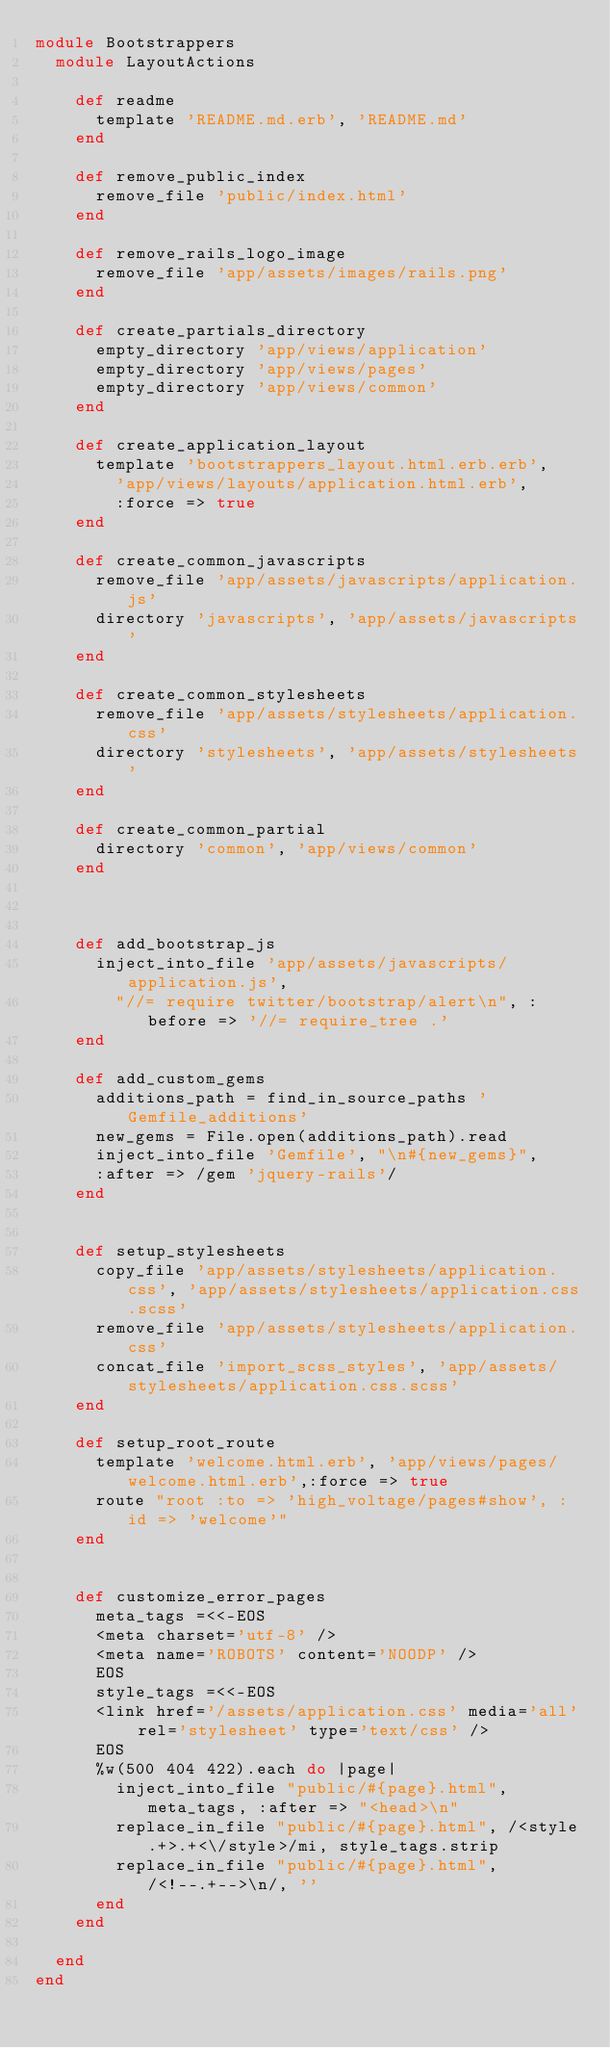Convert code to text. <code><loc_0><loc_0><loc_500><loc_500><_Ruby_>module Bootstrappers
  module LayoutActions

    def readme
      template 'README.md.erb', 'README.md'
    end

    def remove_public_index
      remove_file 'public/index.html'
    end

    def remove_rails_logo_image
      remove_file 'app/assets/images/rails.png'
    end

    def create_partials_directory
      empty_directory 'app/views/application'
      empty_directory 'app/views/pages'
      empty_directory 'app/views/common'
    end

    def create_application_layout
      template 'bootstrappers_layout.html.erb.erb',
        'app/views/layouts/application.html.erb',
        :force => true
    end

    def create_common_javascripts
      remove_file 'app/assets/javascripts/application.js'
      directory 'javascripts', 'app/assets/javascripts'
    end

    def create_common_stylesheets
      remove_file 'app/assets/stylesheets/application.css'
      directory 'stylesheets', 'app/assets/stylesheets'
    end

    def create_common_partial
      directory 'common', 'app/views/common'
    end



    def add_bootstrap_js
      inject_into_file 'app/assets/javascripts/application.js',
        "//= require twitter/bootstrap/alert\n", :before => '//= require_tree .'
    end

    def add_custom_gems
      additions_path = find_in_source_paths 'Gemfile_additions'
      new_gems = File.open(additions_path).read
      inject_into_file 'Gemfile', "\n#{new_gems}",
      :after => /gem 'jquery-rails'/
    end


    def setup_stylesheets
      copy_file 'app/assets/stylesheets/application.css', 'app/assets/stylesheets/application.css.scss'
      remove_file 'app/assets/stylesheets/application.css'
      concat_file 'import_scss_styles', 'app/assets/stylesheets/application.css.scss'
    end

    def setup_root_route
      template 'welcome.html.erb', 'app/views/pages/welcome.html.erb',:force => true
      route "root :to => 'high_voltage/pages#show', :id => 'welcome'"
    end


    def customize_error_pages
      meta_tags =<<-EOS
      <meta charset='utf-8' />
      <meta name='ROBOTS' content='NOODP' />
      EOS
      style_tags =<<-EOS
      <link href='/assets/application.css' media='all' rel='stylesheet' type='text/css' />
      EOS
      %w(500 404 422).each do |page|
        inject_into_file "public/#{page}.html", meta_tags, :after => "<head>\n"
        replace_in_file "public/#{page}.html", /<style.+>.+<\/style>/mi, style_tags.strip
        replace_in_file "public/#{page}.html", /<!--.+-->\n/, ''
      end
    end

  end
end
</code> 